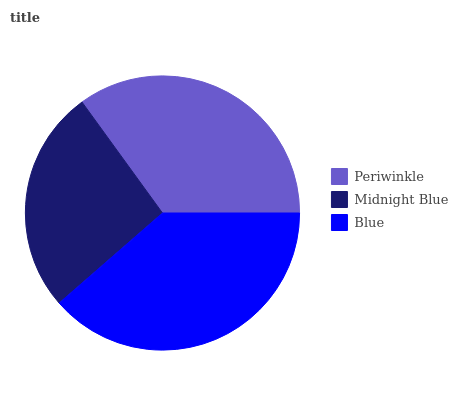Is Midnight Blue the minimum?
Answer yes or no. Yes. Is Blue the maximum?
Answer yes or no. Yes. Is Blue the minimum?
Answer yes or no. No. Is Midnight Blue the maximum?
Answer yes or no. No. Is Blue greater than Midnight Blue?
Answer yes or no. Yes. Is Midnight Blue less than Blue?
Answer yes or no. Yes. Is Midnight Blue greater than Blue?
Answer yes or no. No. Is Blue less than Midnight Blue?
Answer yes or no. No. Is Periwinkle the high median?
Answer yes or no. Yes. Is Periwinkle the low median?
Answer yes or no. Yes. Is Blue the high median?
Answer yes or no. No. Is Blue the low median?
Answer yes or no. No. 